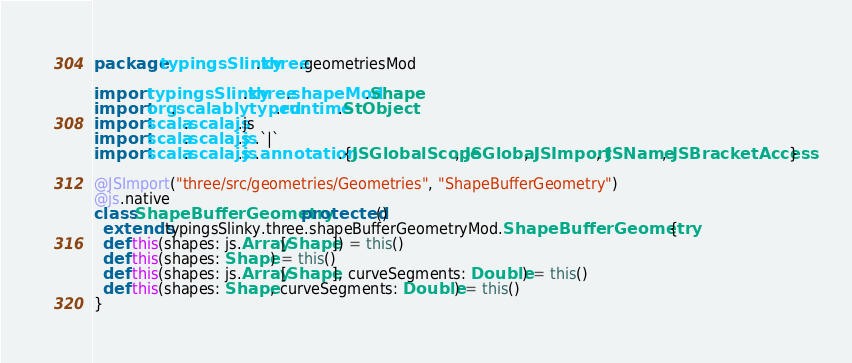<code> <loc_0><loc_0><loc_500><loc_500><_Scala_>package typingsSlinky.three.geometriesMod

import typingsSlinky.three.shapeMod.Shape
import org.scalablytyped.runtime.StObject
import scala.scalajs.js
import scala.scalajs.js.`|`
import scala.scalajs.js.annotation.{JSGlobalScope, JSGlobal, JSImport, JSName, JSBracketAccess}

@JSImport("three/src/geometries/Geometries", "ShapeBufferGeometry")
@js.native
class ShapeBufferGeometry protected ()
  extends typingsSlinky.three.shapeBufferGeometryMod.ShapeBufferGeometry {
  def this(shapes: js.Array[Shape]) = this()
  def this(shapes: Shape) = this()
  def this(shapes: js.Array[Shape], curveSegments: Double) = this()
  def this(shapes: Shape, curveSegments: Double) = this()
}
</code> 